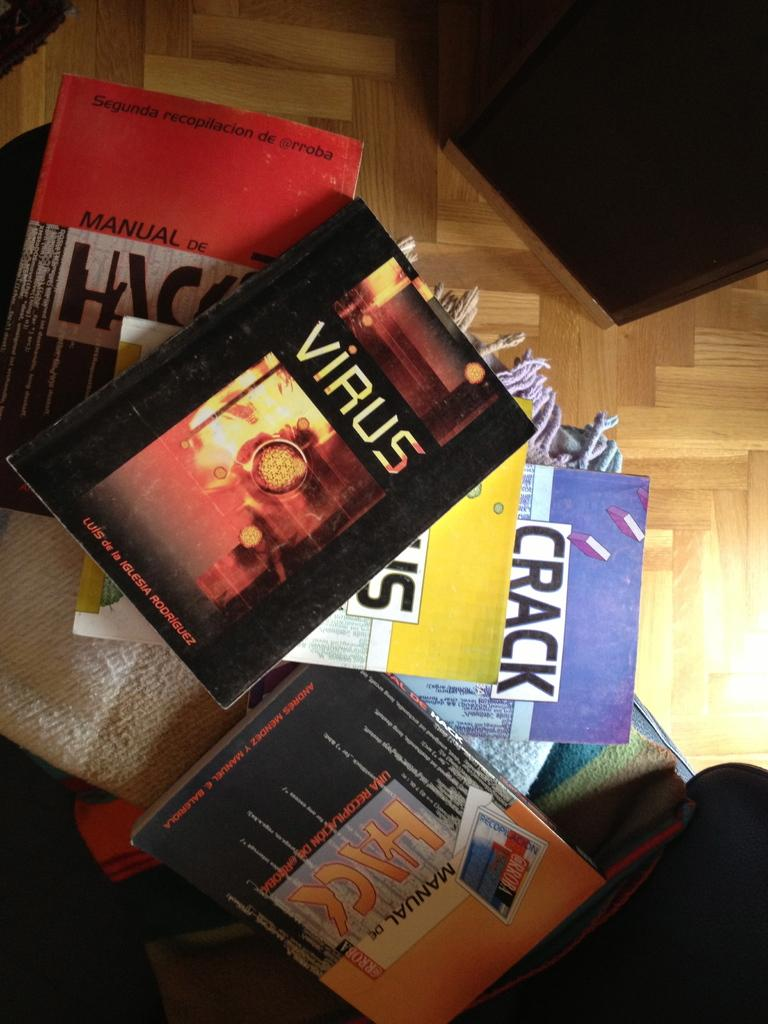<image>
Share a concise interpretation of the image provided. An arrangement of books lies on a wood floor and features Virus by Iglesia Rodriguez. 